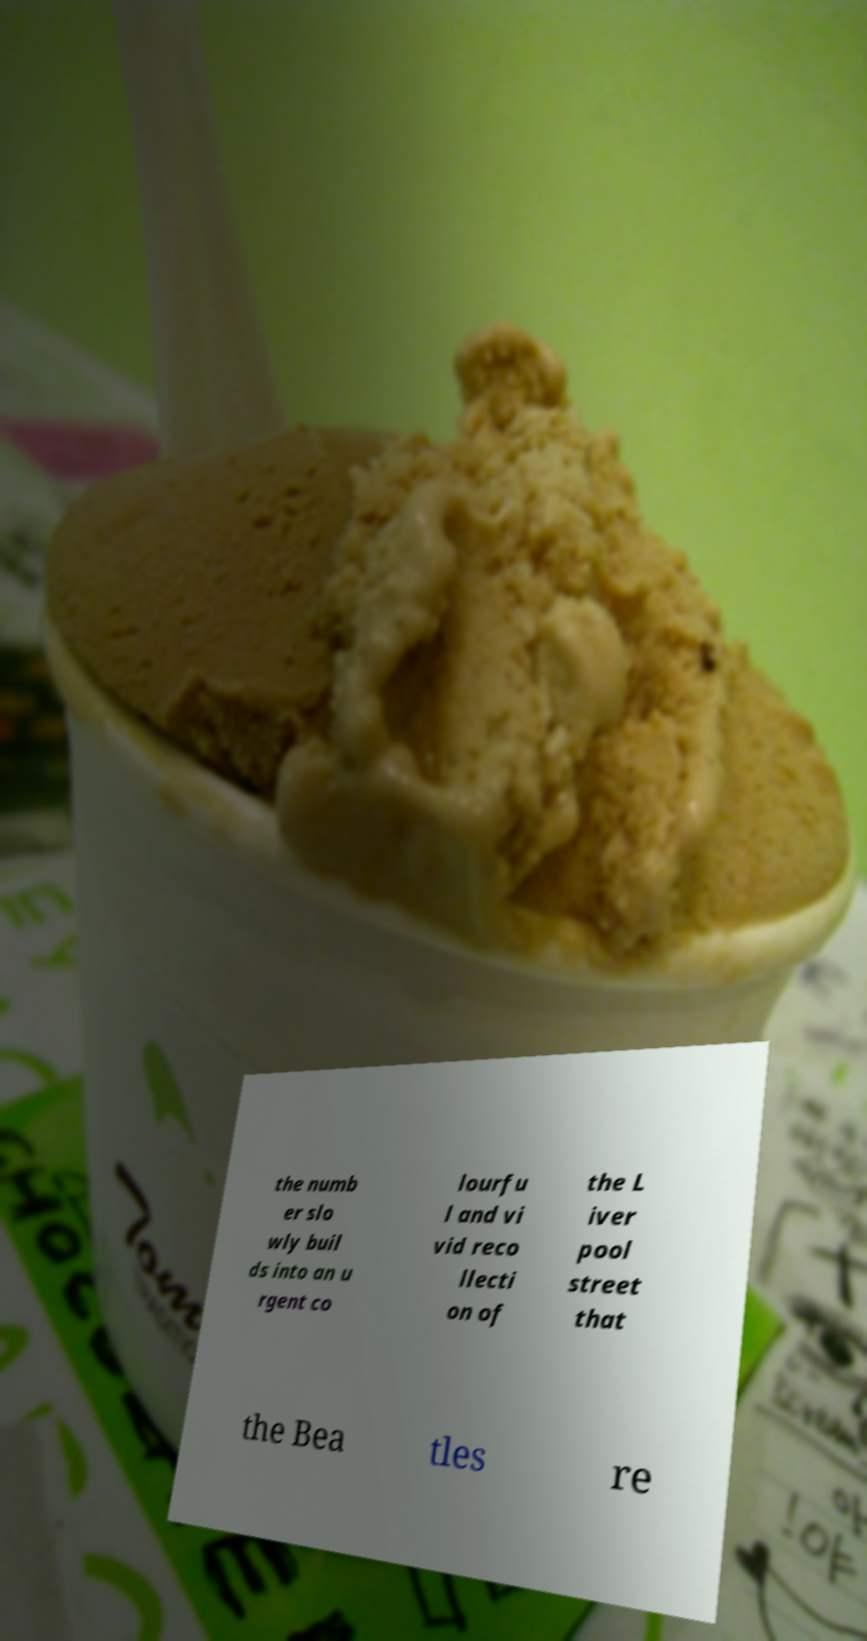Please identify and transcribe the text found in this image. the numb er slo wly buil ds into an u rgent co lourfu l and vi vid reco llecti on of the L iver pool street that the Bea tles re 